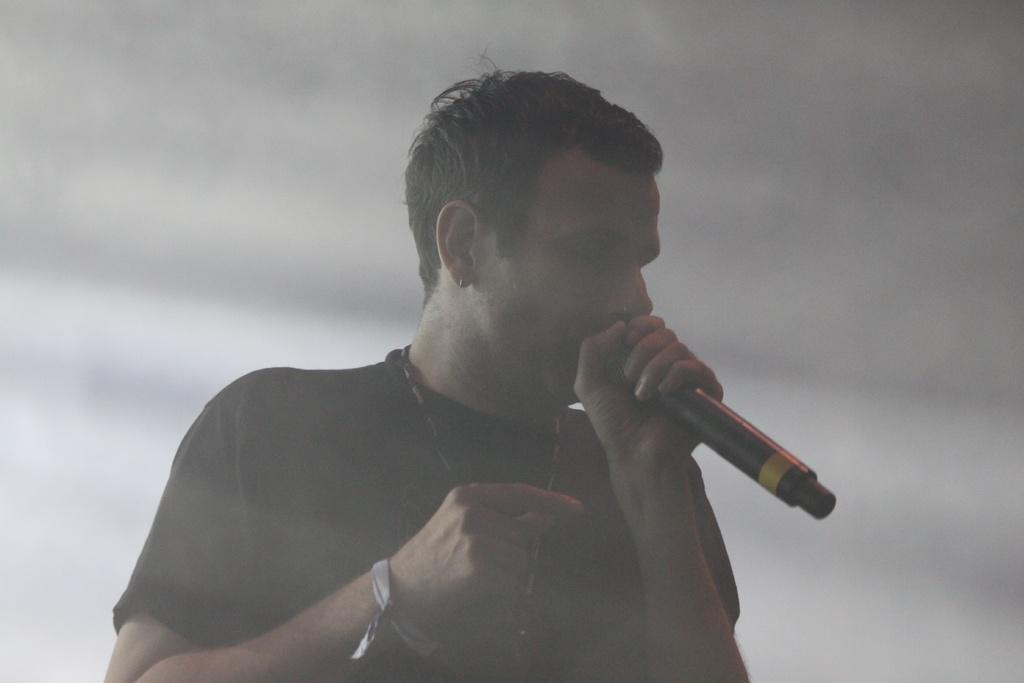Who is the main subject in the image? There is a man in the image. What is the man wearing? The man is wearing a black t-shirt. What is the man holding in the image? The man is holding a microphone. What is the man doing in the image? The man is singing a song. What can be seen behind the man in the image? There is smoke visible behind the man. What type of holiday is the man celebrating in the image? There is no indication of a holiday in the image; it simply shows a man singing with a microphone and smoke behind him. How hot is the floor in the image? The image does not provide any information about the temperature of the floor. 